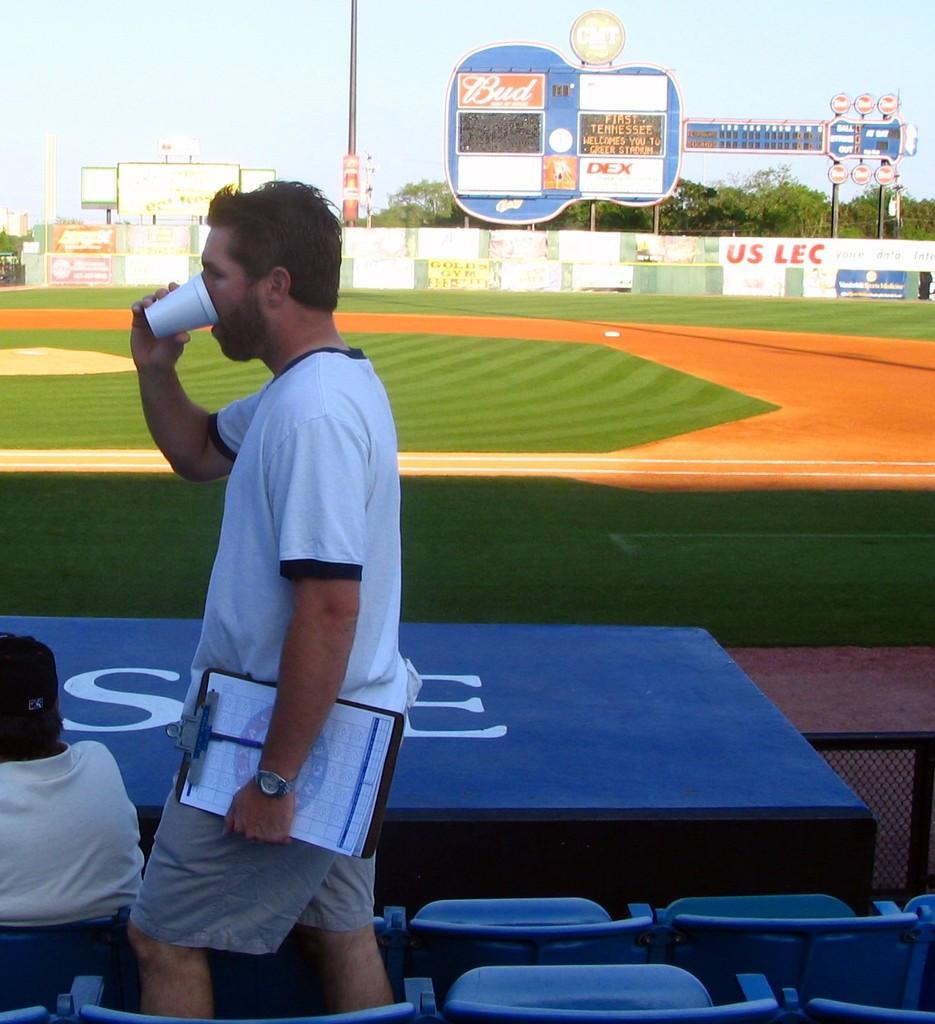<image>
Write a terse but informative summary of the picture. The beer Bud sponsors the team at this baseball field. 